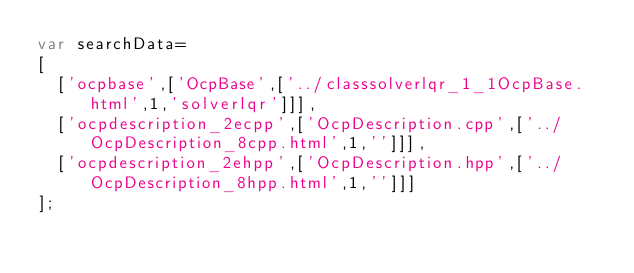<code> <loc_0><loc_0><loc_500><loc_500><_JavaScript_>var searchData=
[
  ['ocpbase',['OcpBase',['../classsolverlqr_1_1OcpBase.html',1,'solverlqr']]],
  ['ocpdescription_2ecpp',['OcpDescription.cpp',['../OcpDescription_8cpp.html',1,'']]],
  ['ocpdescription_2ehpp',['OcpDescription.hpp',['../OcpDescription_8hpp.html',1,'']]]
];
</code> 